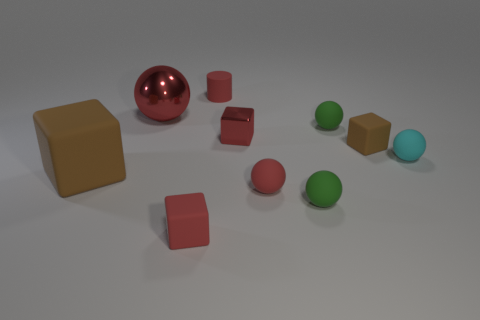Subtract all cylinders. How many objects are left? 9 Add 6 cylinders. How many cylinders are left? 7 Add 2 red matte spheres. How many red matte spheres exist? 3 Subtract 0 purple balls. How many objects are left? 10 Subtract all small spheres. Subtract all small red shiny objects. How many objects are left? 5 